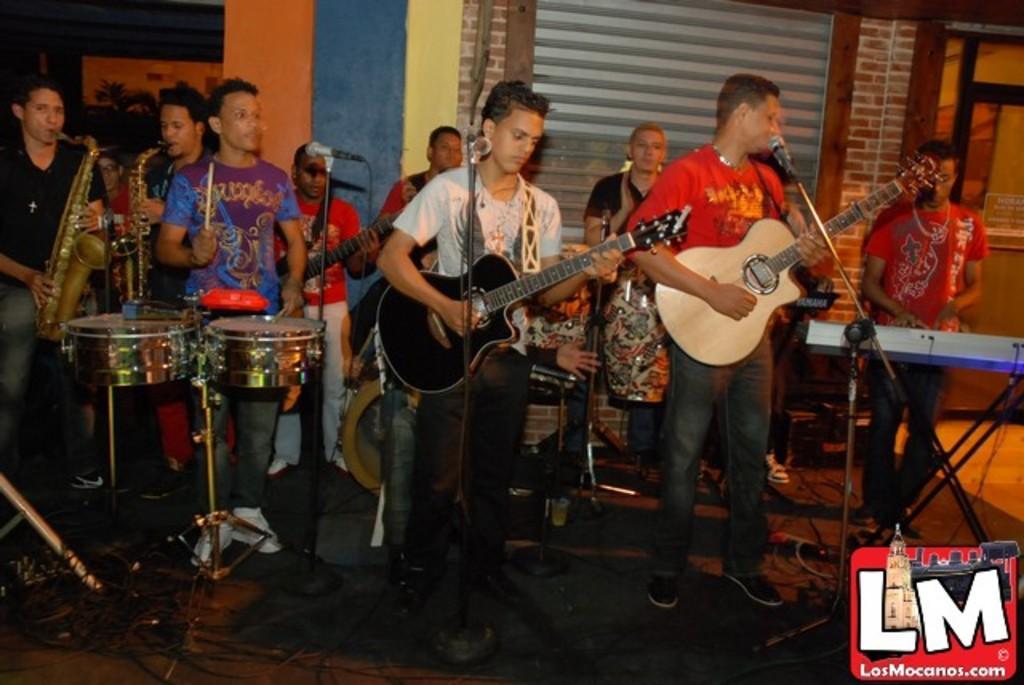How would you summarize this image in a sentence or two? In this picture there are group of people who are standing and playing musical instruments. There is a mic. 